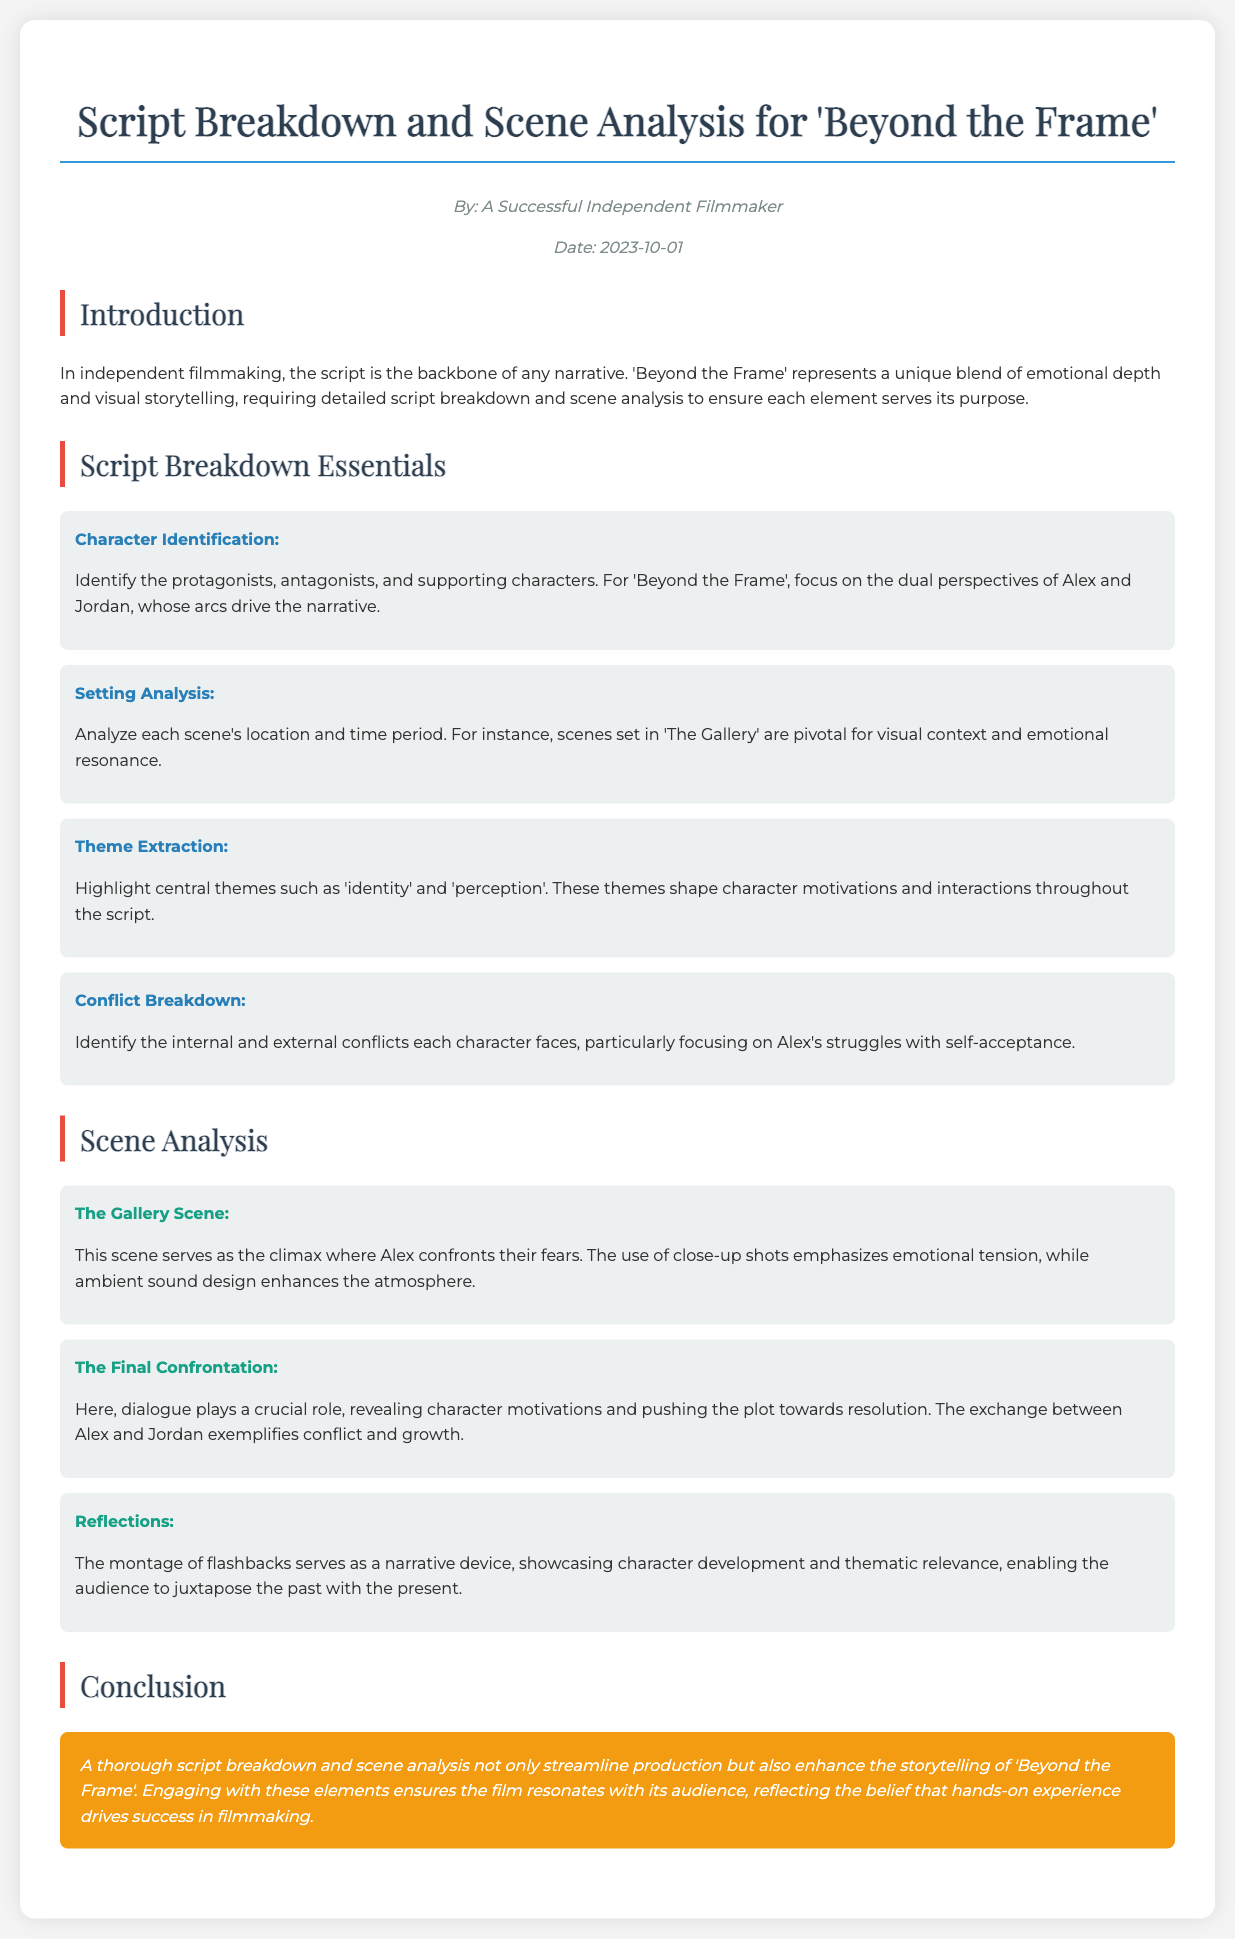What is the title of the manual? The title of the manual is explicitly stated at the beginning of the document.
Answer: Script Breakdown and Scene Analysis for 'Beyond the Frame' Who is the author of this document? The author is mentioned in the author-date section of the document.
Answer: A Successful Independent Filmmaker When was the document published? The publication date is provided in the author-date section of the document.
Answer: 2023-10-01 What are the two main characters identified in the script breakdown? The specific characters are highlighted in the character identification section.
Answer: Alex and Jordan What location is pivotal for visual context in the film? The importance of this location is emphasized in the setting analysis section.
Answer: The Gallery What is one central theme discussed in the script breakdown? The theme is highlighted in the theme extraction section of the document.
Answer: identity Which scene serves as the climax of the film? This information is specified in the scene analysis section.
Answer: The Gallery Scene What narrative device is used in the "Reflections" scene? The type of device used is mentioned in the analysis of the scene.
Answer: montage of flashbacks What is the main purpose of a script breakdown according to the conclusion? The purpose is summarized in the final paragraph of the document.
Answer: streamline production 